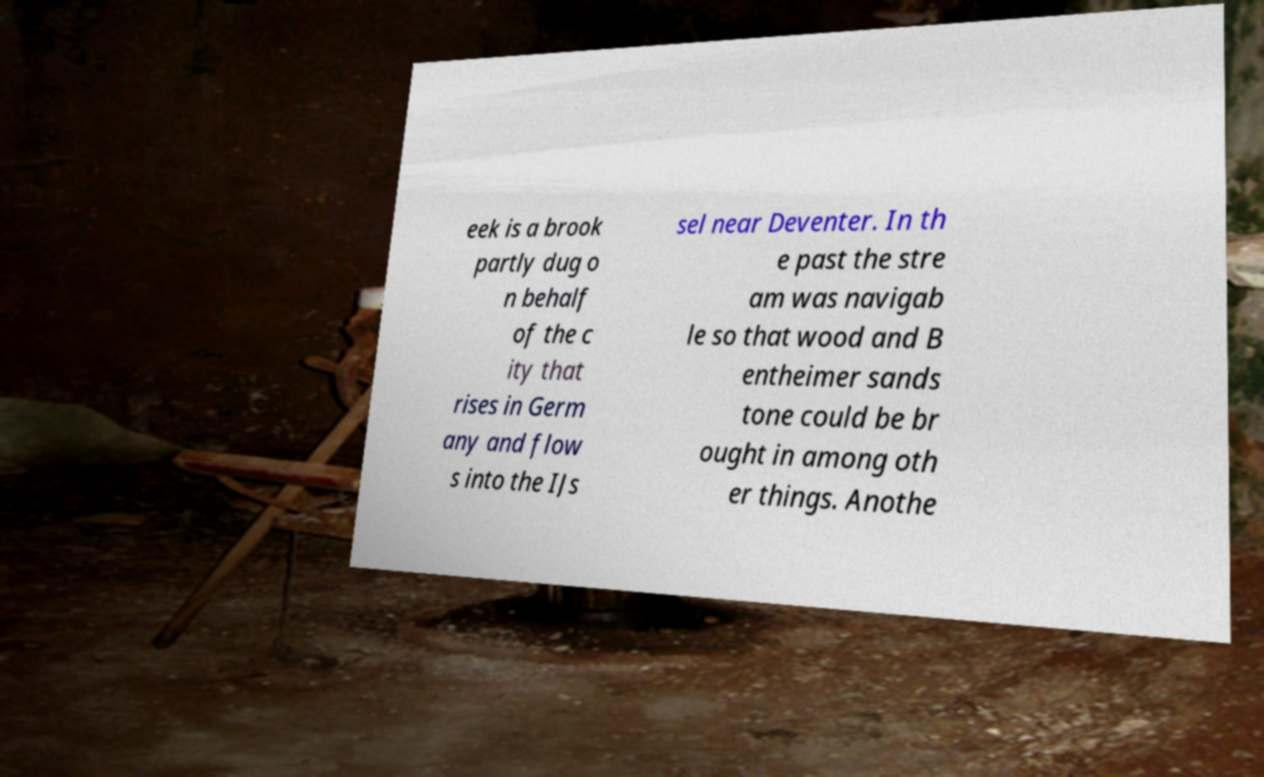For documentation purposes, I need the text within this image transcribed. Could you provide that? eek is a brook partly dug o n behalf of the c ity that rises in Germ any and flow s into the IJs sel near Deventer. In th e past the stre am was navigab le so that wood and B entheimer sands tone could be br ought in among oth er things. Anothe 